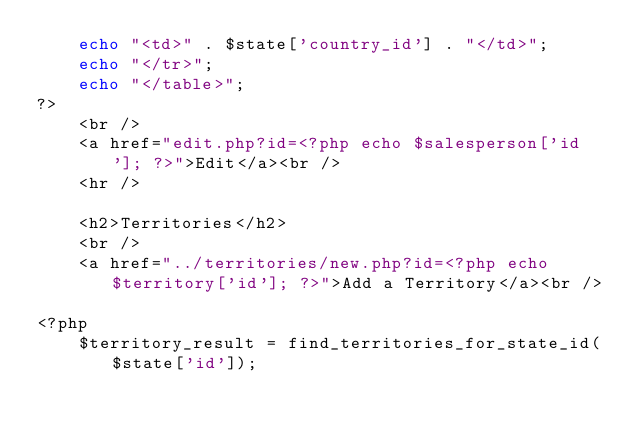<code> <loc_0><loc_0><loc_500><loc_500><_PHP_>    echo "<td>" . $state['country_id'] . "</td>";
    echo "</tr>";
    echo "</table>";
?>
    <br />
    <a href="edit.php?id=<?php echo $salesperson['id']; ?>">Edit</a><br />
    <hr />

    <h2>Territories</h2>
    <br />
    <a href="../territories/new.php?id=<?php echo $territory['id']; ?>">Add a Territory</a><br />

<?php
    $territory_result = find_territories_for_state_id($state['id']);
</code> 